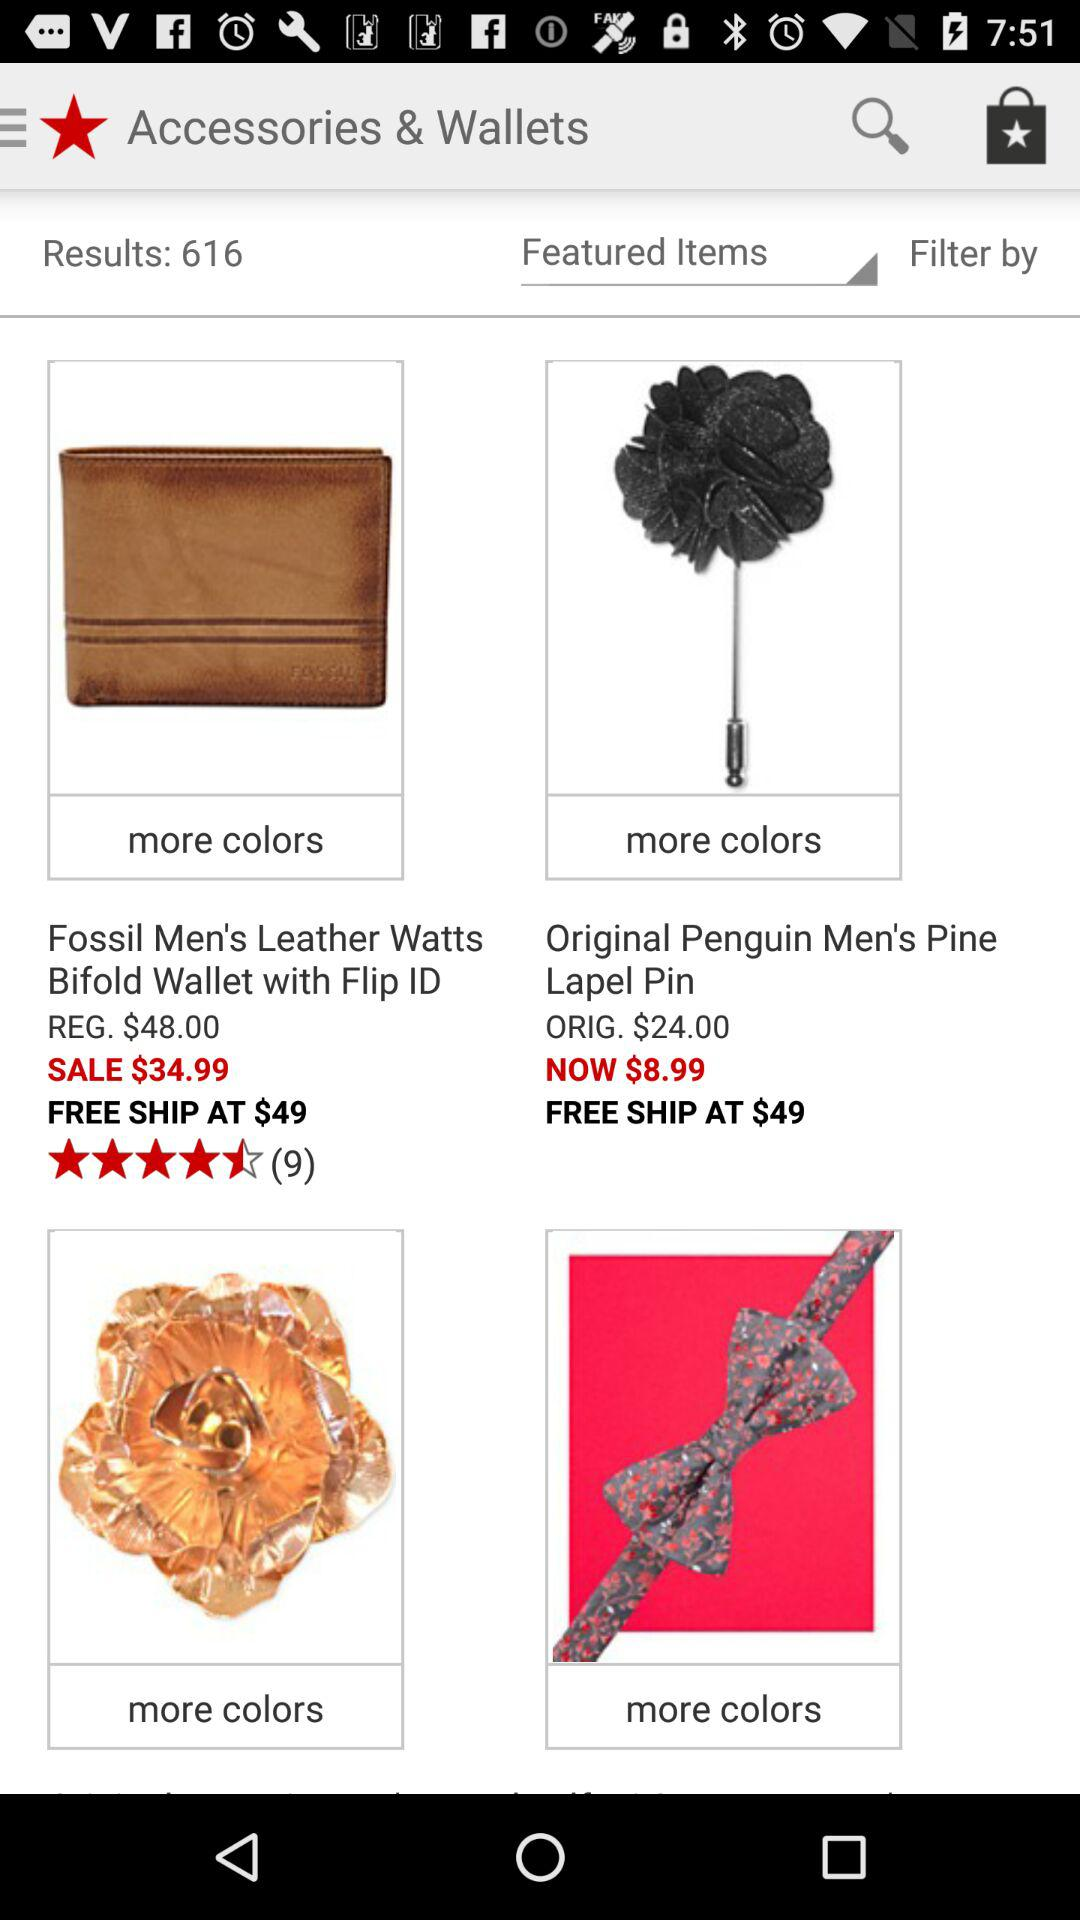How many items are on this screen?
Answer the question using a single word or phrase. 4 